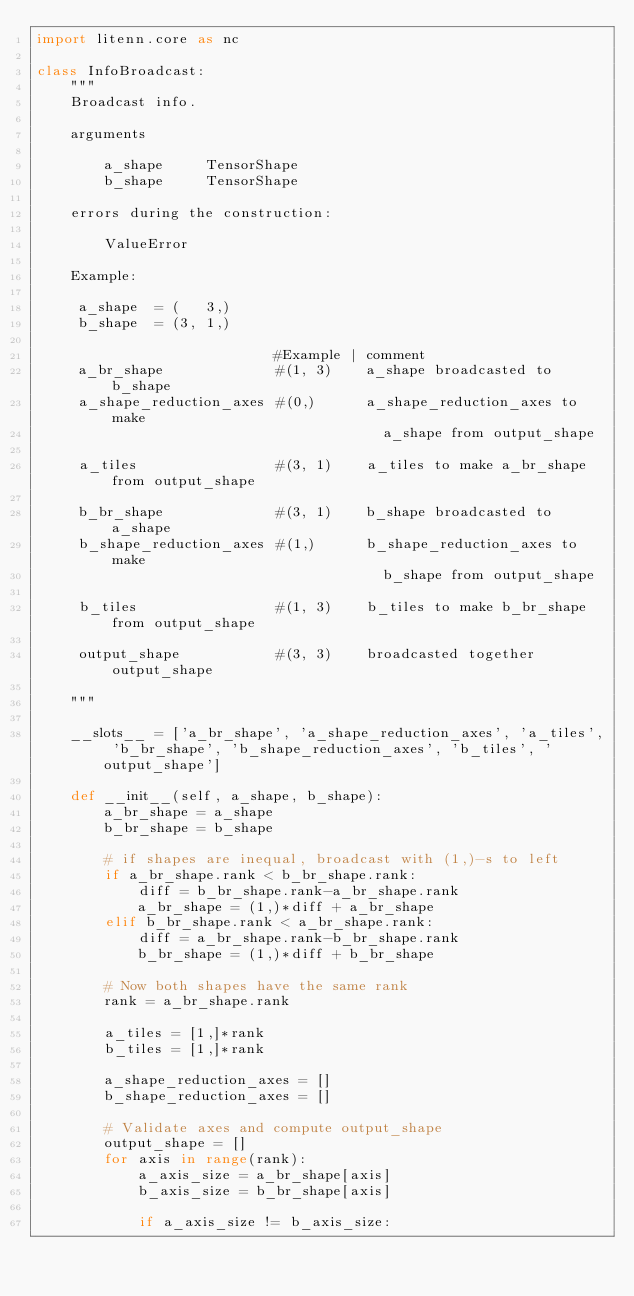Convert code to text. <code><loc_0><loc_0><loc_500><loc_500><_Python_>import litenn.core as nc

class InfoBroadcast:
    """
    Broadcast info.

    arguments

        a_shape     TensorShape
        b_shape     TensorShape

    errors during the construction:

        ValueError

    Example:

     a_shape  = (   3,)
     b_shape  = (3, 1,)

                            #Example | comment
     a_br_shape             #(1, 3)    a_shape broadcasted to b_shape
     a_shape_reduction_axes #(0,)      a_shape_reduction_axes to make
                                         a_shape from output_shape
                                         
     a_tiles                #(3, 1)    a_tiles to make a_br_shape from output_shape

     b_br_shape             #(3, 1)    b_shape broadcasted to a_shape
     b_shape_reduction_axes #(1,)      b_shape_reduction_axes to make
                                         b_shape from output_shape
                                         
     b_tiles                #(1, 3)    b_tiles to make b_br_shape from output_shape

     output_shape           #(3, 3)    broadcasted together output_shape

    """

    __slots__ = ['a_br_shape', 'a_shape_reduction_axes', 'a_tiles', 'b_br_shape', 'b_shape_reduction_axes', 'b_tiles', 'output_shape']

    def __init__(self, a_shape, b_shape):
        a_br_shape = a_shape
        b_br_shape = b_shape

        # if shapes are inequal, broadcast with (1,)-s to left
        if a_br_shape.rank < b_br_shape.rank:
            diff = b_br_shape.rank-a_br_shape.rank
            a_br_shape = (1,)*diff + a_br_shape
        elif b_br_shape.rank < a_br_shape.rank:
            diff = a_br_shape.rank-b_br_shape.rank
            b_br_shape = (1,)*diff + b_br_shape

        # Now both shapes have the same rank
        rank = a_br_shape.rank

        a_tiles = [1,]*rank
        b_tiles = [1,]*rank

        a_shape_reduction_axes = []
        b_shape_reduction_axes = []

        # Validate axes and compute output_shape
        output_shape = []
        for axis in range(rank):
            a_axis_size = a_br_shape[axis]
            b_axis_size = b_br_shape[axis]

            if a_axis_size != b_axis_size:</code> 